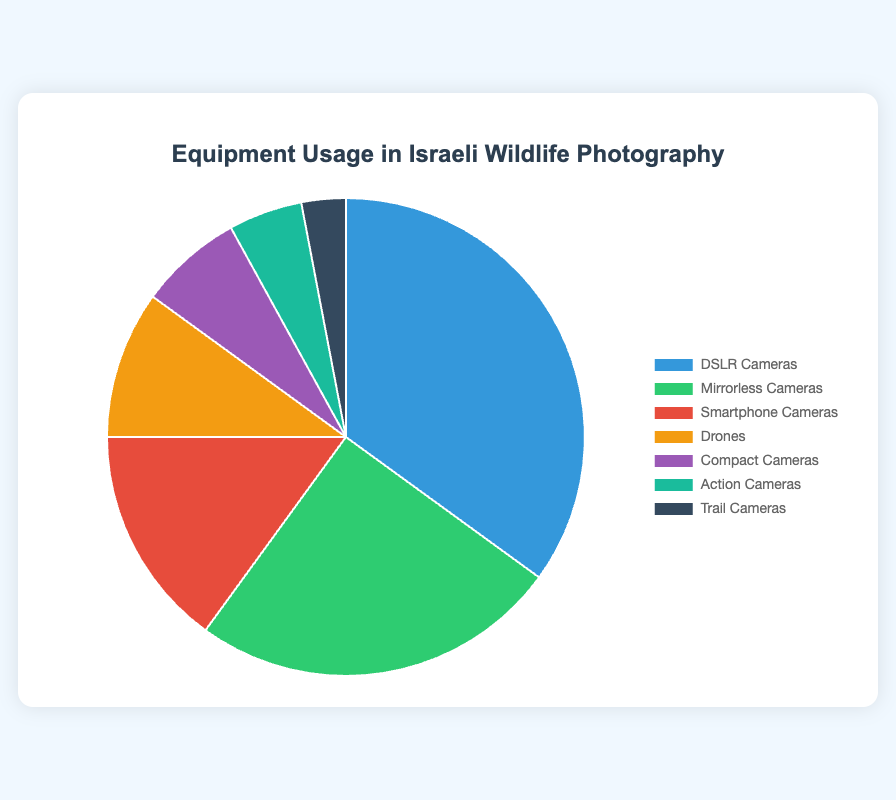What percentage of wildlife photographers use Mirrorless Cameras and Compact Cameras combined? First, find the percentages for Mirrorless Cameras (25%) and Compact Cameras (7%). Next, add them together: 25% + 7% = 32%.
Answer: 32% Which type of camera is used more frequently, Action Cameras or Drones? Compare the percentages of Action Cameras (5%) and Drones (10%). Drones have a higher percentage.
Answer: Drones How much greater is the usage of DSLR Cameras compared to Trail Cameras? Subtract the percentage of Trail Cameras (3%) from the percentage of DSLR Cameras (35%). 35% - 3% = 32%.
Answer: 32% Is the usage of Smartphone Cameras greater than the combined usage of Action Cameras and Trail Cameras? Add the percentages of Action Cameras (5%) and Trail Cameras (3%) to get a combined usage of 8%. The percentage for Smartphone Cameras is 15%, which is greater than 8%.
Answer: Yes Which category takes up the largest portion of the pie chart, and what is its percentage? Observing the pie chart, the largest segment is DSLR Cameras with 35%.
Answer: DSLR Cameras with 35% How does the combined usage of Drones and Compact Cameras compare to the usage of Mirrorless Cameras? Add the percentages for Drones (10%) and Compact Cameras (7%) to get 17%. Compare it to the percentage for Mirrorless Cameras, which is 25%. 25% is greater than 17%.
Answer: Mirrorless Cameras have higher usage What is the most frequently used type of camera in Israeli wildlife photography? By looking at the frequencies, DSLR Cameras have the highest usage at 35%.
Answer: DSLR Cameras Are Action Cameras used more or less than Smartphone Cameras? Compare the percentages: Action Cameras (5%) and Smartphone Cameras (15%). Action Cameras are used less.
Answer: Less What is the combined percentage of the least used categories, which are Action Cameras and Trail Cameras? Add percentages for Action Cameras (5%) and Trail Cameras (3%) to get 5% + 3% = 8%.
Answer: 8% What fraction of the pie chart is taken up by cameras other than DSLR Cameras? Subtract the percentage of DSLR Cameras (35%) from 100%: 100% - 35% = 65%.
Answer: 65% 